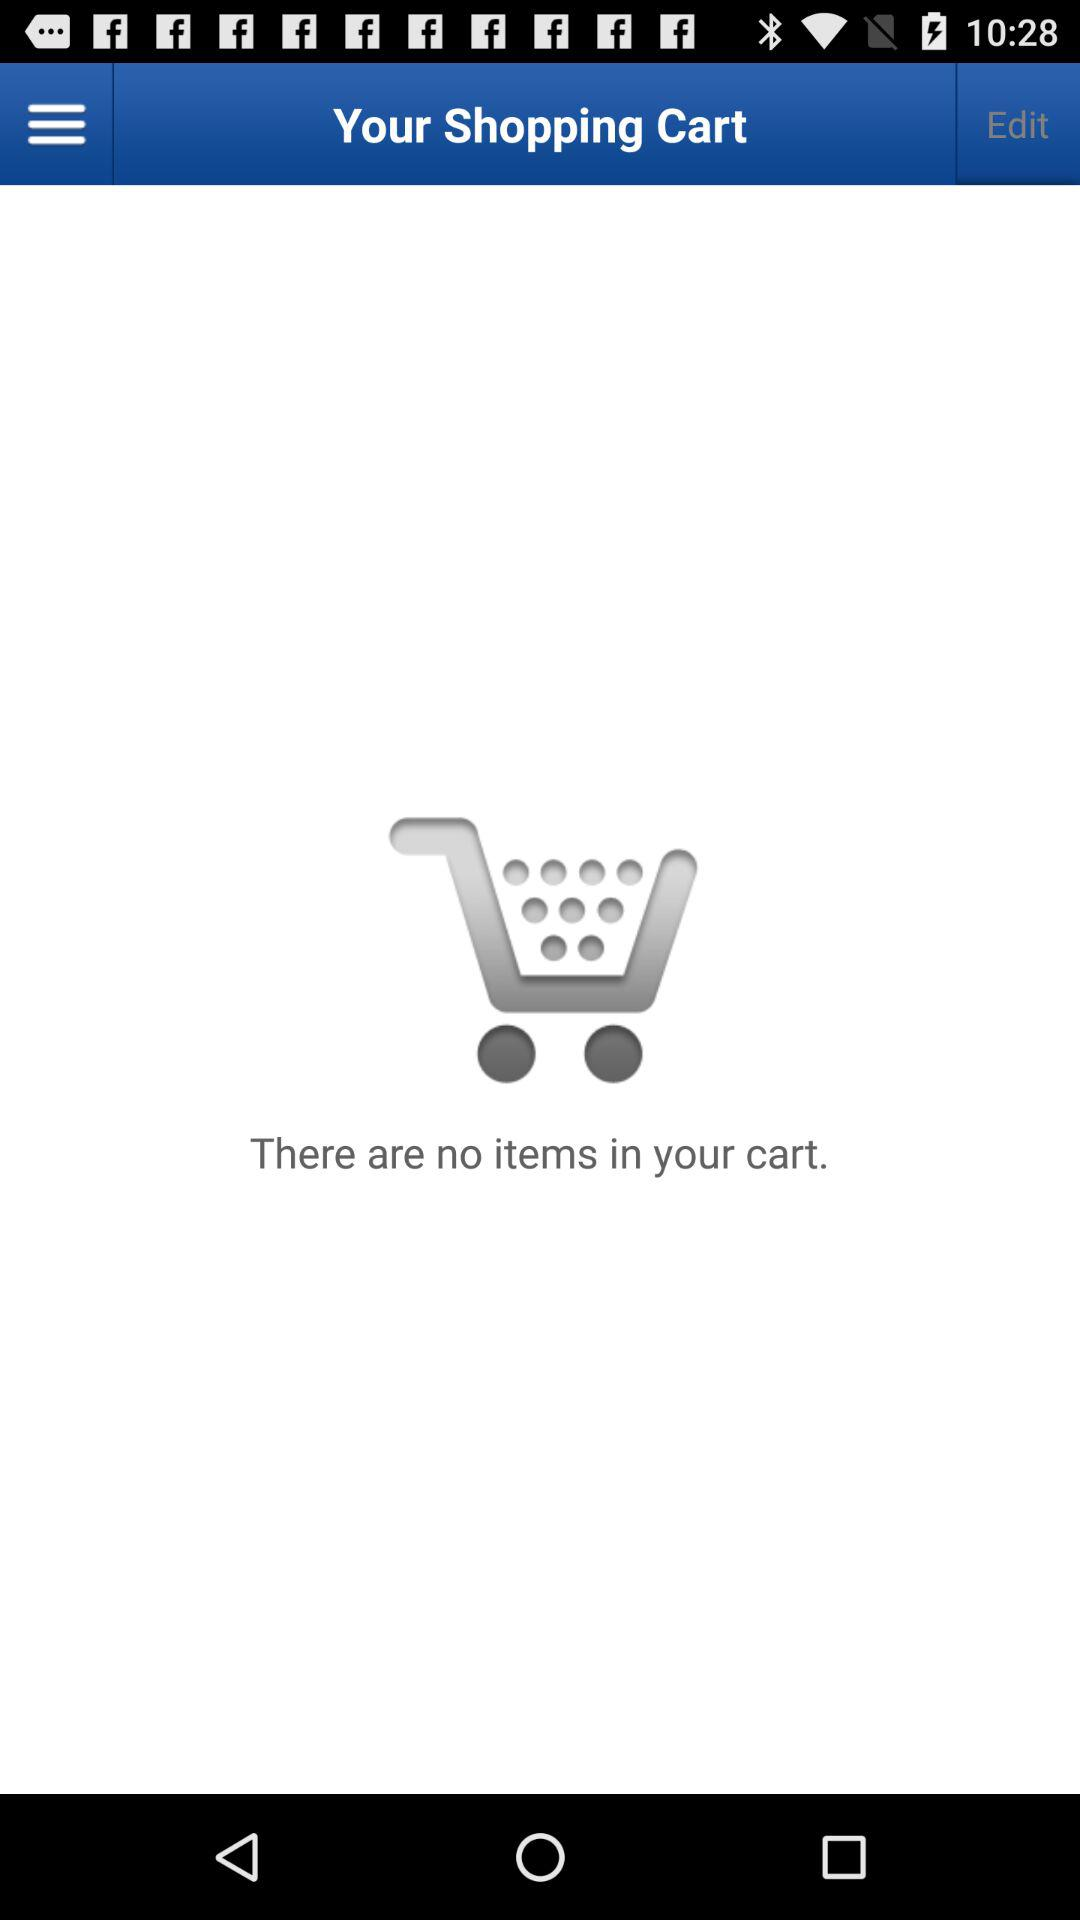How many items are in the cart?
Answer the question using a single word or phrase. 0 